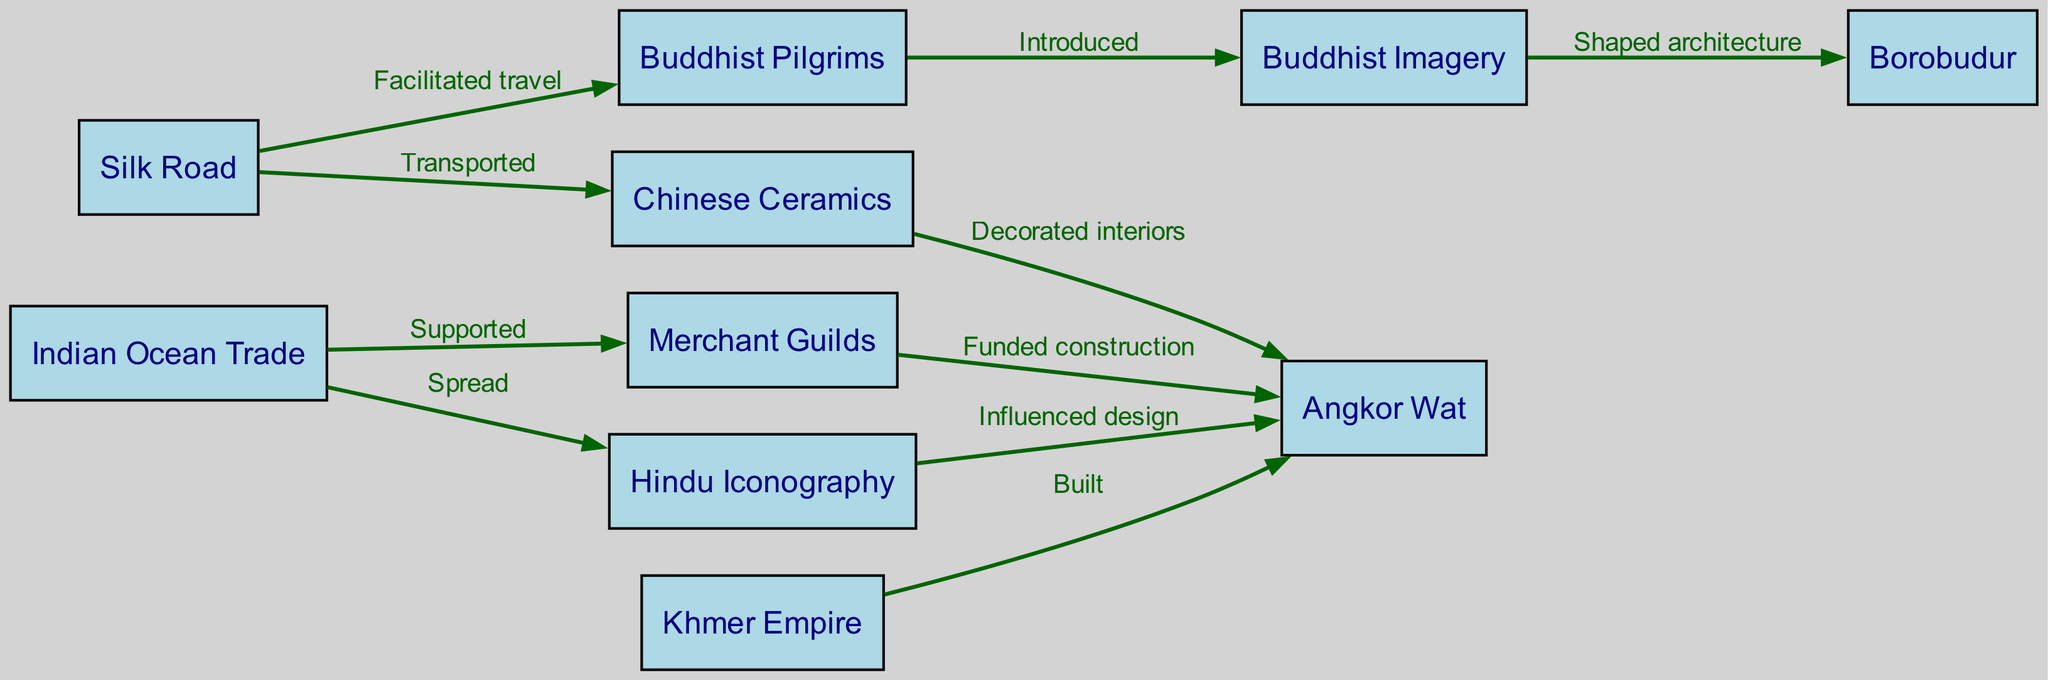What is the total number of nodes in the diagram? The diagram lists several items under nodes. By counting them, we find that there are 10 nodes present in total: Silk Road, Indian Ocean Trade, Buddhist Pilgrims, Merchant Guilds, Khmer Empire, Angkor Wat, Borobudur, Hindu Iconography, Buddhist Imagery, and Chinese Ceramics.
Answer: 10 What are the two routes that led to the construction of Angkor Wat? To understand how Angkor Wat was constructed, we look at the edges leading into Angkor Wat. The diagram shows two edges: one from Merchant Guilds labeled "Funded construction" and another from the Khmer Empire labeled "Built." Both contribute to the construction of Angkor Wat.
Answer: Merchant Guilds and Khmer Empire Which trade route transported Chinese Ceramics? The edge labeled "Transported" leads from the Silk Road to Chinese Ceramics, indicating that this trade route was responsible for this transportation.
Answer: Silk Road What influence did Buddhist Pilgrims have on Buddhist Imagery? The diagram showcases an edge from Buddhist Pilgrims to Buddhist Imagery labeled "Introduced." This suggests that Buddhist Pilgrims played a direct role in the introduction of Buddhist Imagery.
Answer: Introduced How did Hindu Iconography influence the design of Angkor Wat? There is an edge labeled "Influenced design" that connects Hindu Iconography to Angkor Wat. This indicates that the symbolisms and motifs from Hindu Iconography were incorporated into the overall design of Angkor Wat.
Answer: Influenced design What type of trade supported Merchant Guilds? The diagram shows an edge labeled "Supported" that connects the Indian Ocean Trade to Merchant Guilds. This implies that the Indian Ocean Trade was fundamental in providing the necessary support for Merchant Guilds.
Answer: Supported Which architectural structure was shaped by Buddhist Imagery? The edge labeled "Shaped architecture" indicates a connection from Buddhist Imagery to Borobudur. This connection clearly shows that Buddhist Imagery had a formative impact on the architecture of Borobudur.
Answer: Borobudur How many edges lead out from the Silk Road? By reviewing the edges stemming from the Silk Road, we find that there are three edges: one to Buddhist Pilgrims labeled "Facilitated travel," one to Chinese Ceramics labeled "Transported," and one to Hindu Iconography indirectly through the flows. This gives us a clear count of the edges.
Answer: Three 